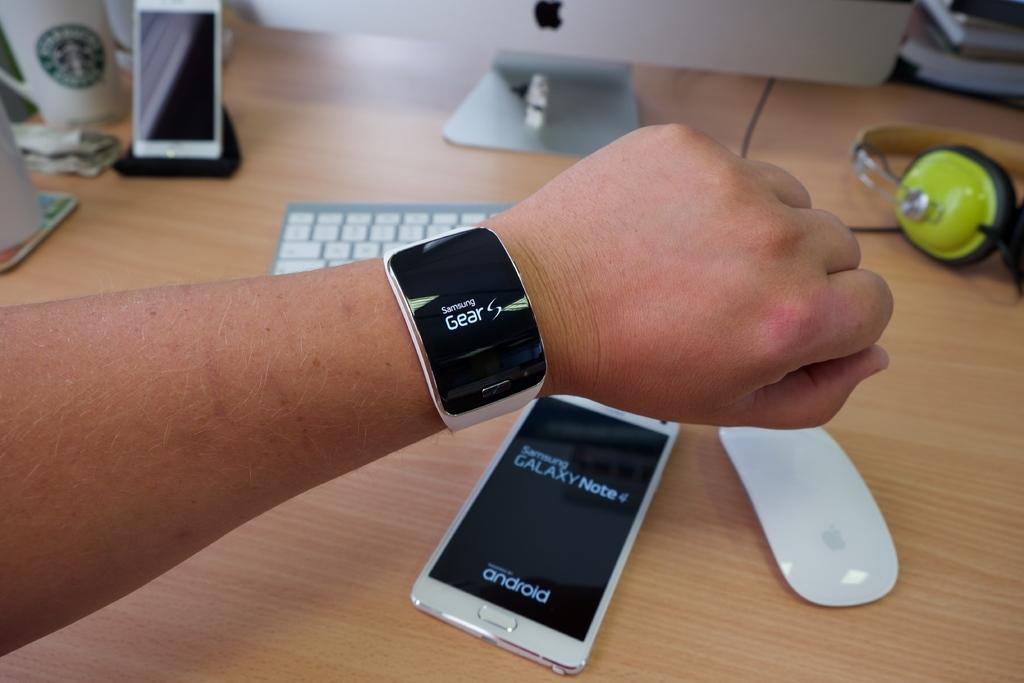<image>
Render a clear and concise summary of the photo. a Samsung Galaxy phone and a smartwatch on a wrist 